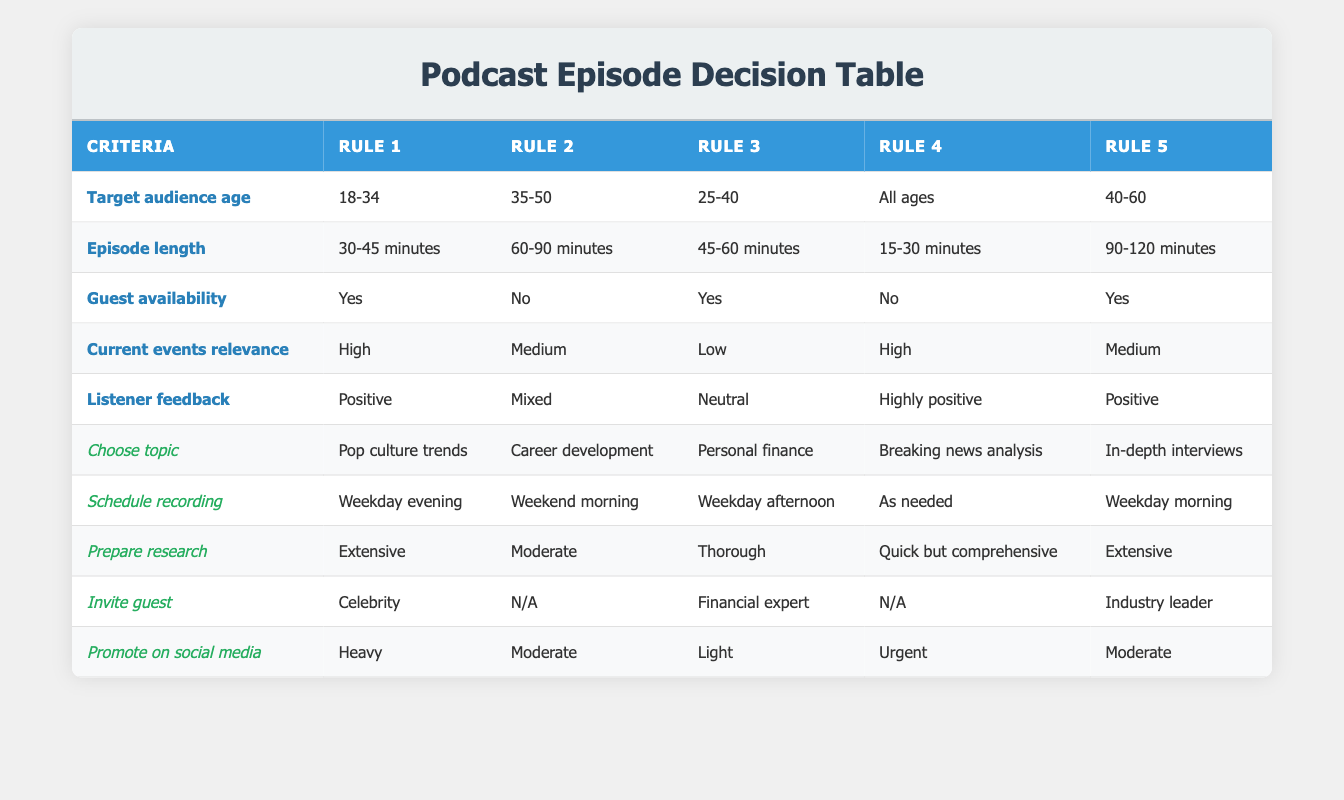What is the topic chosen for the first rule? The first rule corresponds to a target audience age of 18-34, with a current events relevance of high and positive listener feedback. According to the table, the chosen topic for this rule is "Pop culture trends."
Answer: Pop culture trends Is there a rule that involves guest availability of "No"? Yes, the second rule (target audience age 35-50) and the fourth rule (target audience age All ages) both indicate that guest availability is "No."
Answer: Yes What is the average episode length for rules with positive listener feedback? The rules with positive listener feedback are rules 1, 2, and 5. Their episode lengths are 30-45 minutes, 60-90 minutes, and 90-120 minutes respectively. Converting these time ranges to numerical averages: 30-45 minutes averages to 37.5, 60-90 averages to 75, and 90-120 averages to 105. The sum is 37.5 + 75 + 105 = 217. Since there are 3 rules, the average episode length is 217/3 = approximately 72.33 minutes.
Answer: Approximately 72.33 minutes Which rule requires the most extensive preparation for research? The rules that require extensive preparation for research are rules 1 and 5. According to the table, both these rules indicate "Extensive" preparation for research. Therefore, one could select either as the answer, but both do not specify a distinct difference in preparation level.
Answer: Extensive (in rules 1 and 5) Is "Breaking news analysis" chosen for a weekday evening recording schedule? No, "Breaking news analysis" is chosen for a recording schedule "As needed," which does not correspond to a weekday evening schedule. Therefore, the answer is no.
Answer: No 